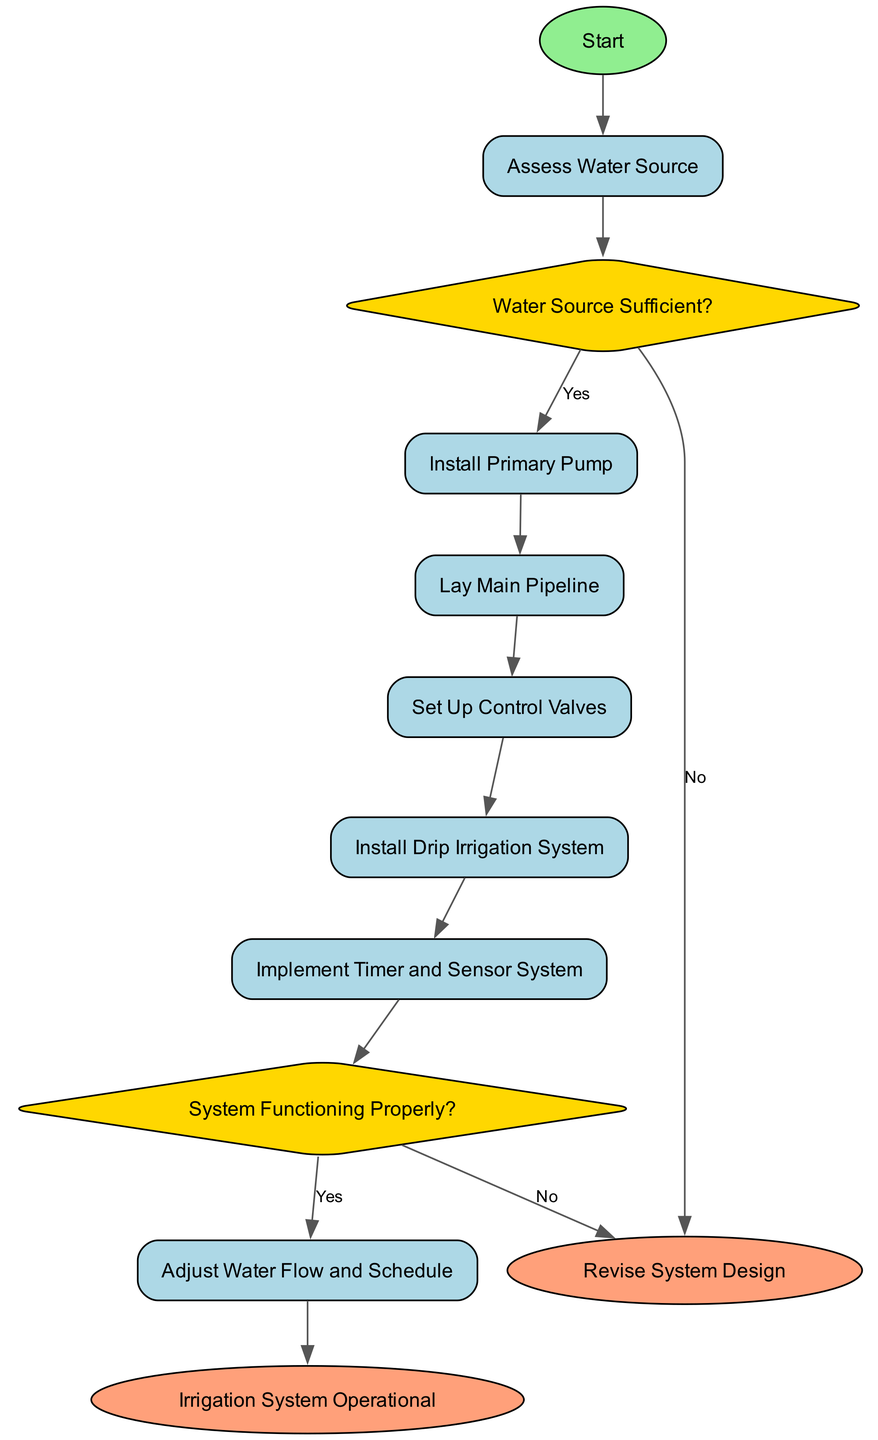What is the first step in the irrigation system setup? The diagram indicates that the first step is to "Assess Water Source." This is the initial node following the start node.
Answer: Assess Water Source How many decision nodes are in the diagram? The diagram has two decision nodes: "Water Source Sufficient?" and "System Functioning Properly?" Count each of these nodes to arrive at the total.
Answer: 2 What is the last step if the irrigation system is functioning properly? According to the diagram, if the system is functioning properly, the last step is to reach the node labeled "Irrigation System Operational." This is the final node leading from the successful check.
Answer: Irrigation System Operational What step occurs after laying the main pipeline? The next step after "Lay Main Pipeline" is "Set Up Control Valves". This indicates a direct progression in the process as detailed in the flow.
Answer: Set Up Control Valves If the water source is not sufficient, where do you return to? If the water source is not sufficient, you go back to the step labeled "Revise System Design," indicating a need to reassess and refine your system design based on identified shortcomings.
Answer: Revise System Design What must be implemented after installing the drip irrigation system? The subsequent step after "Install Drip Irrigation System" is to "Implement Timer and Sensor System." This follows in the logical sequence of managing irrigation effectively.
Answer: Implement Timer and Sensor System Before adjusting water flow and schedule, which step must be verified? You need to check "System Functioning Properly?" before making any adjustments. The process indicates that adjustments are made only if the system is confirmed to be functioning.
Answer: System Functioning Properly? What shape represents the end nodes in the diagram? The end nodes are represented as ellipses in the diagram, which is a specific shape used to indicate completion in flowcharts.
Answer: Ellipses 